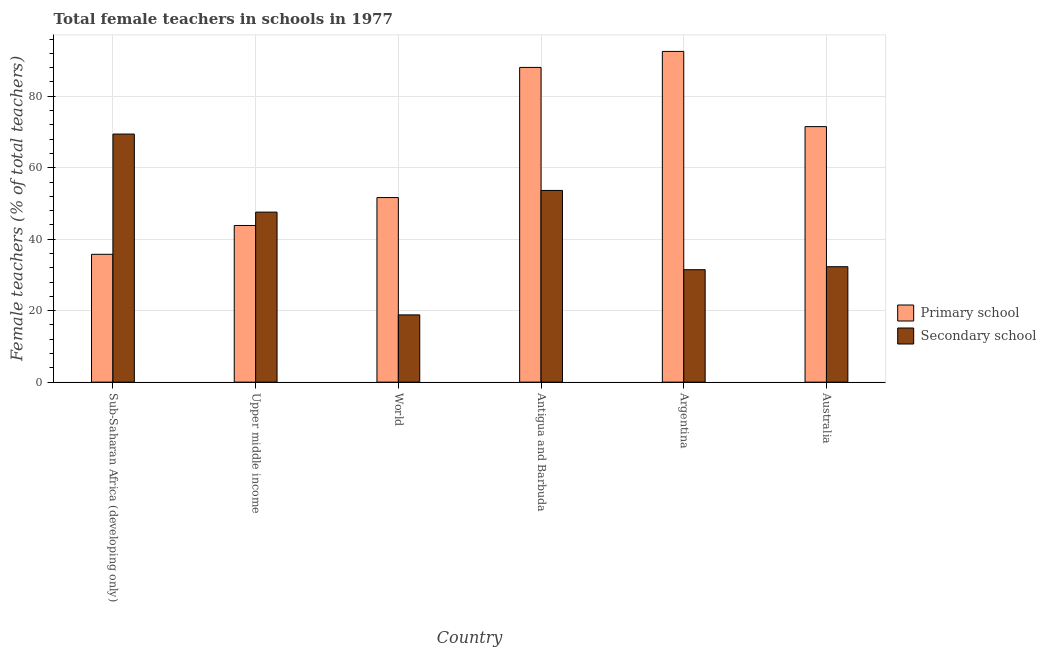How many different coloured bars are there?
Make the answer very short. 2. Are the number of bars per tick equal to the number of legend labels?
Make the answer very short. Yes. How many bars are there on the 2nd tick from the left?
Give a very brief answer. 2. How many bars are there on the 3rd tick from the right?
Make the answer very short. 2. What is the label of the 1st group of bars from the left?
Ensure brevity in your answer.  Sub-Saharan Africa (developing only). What is the percentage of female teachers in primary schools in Australia?
Your answer should be very brief. 71.5. Across all countries, what is the maximum percentage of female teachers in secondary schools?
Keep it short and to the point. 69.42. Across all countries, what is the minimum percentage of female teachers in secondary schools?
Provide a short and direct response. 18.82. In which country was the percentage of female teachers in secondary schools maximum?
Provide a succinct answer. Sub-Saharan Africa (developing only). In which country was the percentage of female teachers in primary schools minimum?
Your response must be concise. Sub-Saharan Africa (developing only). What is the total percentage of female teachers in secondary schools in the graph?
Your answer should be compact. 253.23. What is the difference between the percentage of female teachers in primary schools in Antigua and Barbuda and that in Australia?
Your answer should be very brief. 16.56. What is the difference between the percentage of female teachers in secondary schools in Upper middle income and the percentage of female teachers in primary schools in World?
Your response must be concise. -4.07. What is the average percentage of female teachers in secondary schools per country?
Offer a terse response. 42.21. What is the difference between the percentage of female teachers in secondary schools and percentage of female teachers in primary schools in Sub-Saharan Africa (developing only)?
Ensure brevity in your answer.  33.65. What is the ratio of the percentage of female teachers in primary schools in Antigua and Barbuda to that in World?
Your response must be concise. 1.71. Is the percentage of female teachers in primary schools in Sub-Saharan Africa (developing only) less than that in Upper middle income?
Offer a very short reply. Yes. What is the difference between the highest and the second highest percentage of female teachers in secondary schools?
Provide a short and direct response. 15.77. What is the difference between the highest and the lowest percentage of female teachers in primary schools?
Ensure brevity in your answer.  56.77. In how many countries, is the percentage of female teachers in primary schools greater than the average percentage of female teachers in primary schools taken over all countries?
Ensure brevity in your answer.  3. What does the 1st bar from the left in Sub-Saharan Africa (developing only) represents?
Keep it short and to the point. Primary school. What does the 1st bar from the right in Antigua and Barbuda represents?
Your answer should be very brief. Secondary school. Are all the bars in the graph horizontal?
Your answer should be very brief. No. How many countries are there in the graph?
Make the answer very short. 6. What is the difference between two consecutive major ticks on the Y-axis?
Provide a short and direct response. 20. Are the values on the major ticks of Y-axis written in scientific E-notation?
Provide a short and direct response. No. Does the graph contain grids?
Your response must be concise. Yes. Where does the legend appear in the graph?
Keep it short and to the point. Center right. How many legend labels are there?
Ensure brevity in your answer.  2. How are the legend labels stacked?
Keep it short and to the point. Vertical. What is the title of the graph?
Provide a short and direct response. Total female teachers in schools in 1977. Does "Official creditors" appear as one of the legend labels in the graph?
Ensure brevity in your answer.  No. What is the label or title of the Y-axis?
Provide a succinct answer. Female teachers (% of total teachers). What is the Female teachers (% of total teachers) of Primary school in Sub-Saharan Africa (developing only)?
Keep it short and to the point. 35.77. What is the Female teachers (% of total teachers) in Secondary school in Sub-Saharan Africa (developing only)?
Give a very brief answer. 69.42. What is the Female teachers (% of total teachers) in Primary school in Upper middle income?
Make the answer very short. 43.84. What is the Female teachers (% of total teachers) in Secondary school in Upper middle income?
Your answer should be compact. 47.58. What is the Female teachers (% of total teachers) of Primary school in World?
Your answer should be very brief. 51.65. What is the Female teachers (% of total teachers) in Secondary school in World?
Offer a very short reply. 18.82. What is the Female teachers (% of total teachers) in Primary school in Antigua and Barbuda?
Your answer should be compact. 88.07. What is the Female teachers (% of total teachers) of Secondary school in Antigua and Barbuda?
Provide a short and direct response. 53.65. What is the Female teachers (% of total teachers) in Primary school in Argentina?
Provide a short and direct response. 92.55. What is the Female teachers (% of total teachers) of Secondary school in Argentina?
Your answer should be compact. 31.47. What is the Female teachers (% of total teachers) in Primary school in Australia?
Your response must be concise. 71.5. What is the Female teachers (% of total teachers) in Secondary school in Australia?
Provide a short and direct response. 32.3. Across all countries, what is the maximum Female teachers (% of total teachers) of Primary school?
Your response must be concise. 92.55. Across all countries, what is the maximum Female teachers (% of total teachers) of Secondary school?
Offer a very short reply. 69.42. Across all countries, what is the minimum Female teachers (% of total teachers) of Primary school?
Your answer should be compact. 35.77. Across all countries, what is the minimum Female teachers (% of total teachers) of Secondary school?
Offer a very short reply. 18.82. What is the total Female teachers (% of total teachers) of Primary school in the graph?
Make the answer very short. 383.38. What is the total Female teachers (% of total teachers) in Secondary school in the graph?
Provide a short and direct response. 253.23. What is the difference between the Female teachers (% of total teachers) in Primary school in Sub-Saharan Africa (developing only) and that in Upper middle income?
Offer a very short reply. -8.06. What is the difference between the Female teachers (% of total teachers) of Secondary school in Sub-Saharan Africa (developing only) and that in Upper middle income?
Ensure brevity in your answer.  21.85. What is the difference between the Female teachers (% of total teachers) in Primary school in Sub-Saharan Africa (developing only) and that in World?
Give a very brief answer. -15.87. What is the difference between the Female teachers (% of total teachers) in Secondary school in Sub-Saharan Africa (developing only) and that in World?
Ensure brevity in your answer.  50.6. What is the difference between the Female teachers (% of total teachers) of Primary school in Sub-Saharan Africa (developing only) and that in Antigua and Barbuda?
Give a very brief answer. -52.29. What is the difference between the Female teachers (% of total teachers) of Secondary school in Sub-Saharan Africa (developing only) and that in Antigua and Barbuda?
Make the answer very short. 15.77. What is the difference between the Female teachers (% of total teachers) of Primary school in Sub-Saharan Africa (developing only) and that in Argentina?
Your answer should be very brief. -56.77. What is the difference between the Female teachers (% of total teachers) in Secondary school in Sub-Saharan Africa (developing only) and that in Argentina?
Give a very brief answer. 37.96. What is the difference between the Female teachers (% of total teachers) of Primary school in Sub-Saharan Africa (developing only) and that in Australia?
Make the answer very short. -35.73. What is the difference between the Female teachers (% of total teachers) in Secondary school in Sub-Saharan Africa (developing only) and that in Australia?
Offer a very short reply. 37.12. What is the difference between the Female teachers (% of total teachers) of Primary school in Upper middle income and that in World?
Keep it short and to the point. -7.81. What is the difference between the Female teachers (% of total teachers) of Secondary school in Upper middle income and that in World?
Make the answer very short. 28.76. What is the difference between the Female teachers (% of total teachers) in Primary school in Upper middle income and that in Antigua and Barbuda?
Make the answer very short. -44.23. What is the difference between the Female teachers (% of total teachers) of Secondary school in Upper middle income and that in Antigua and Barbuda?
Provide a succinct answer. -6.07. What is the difference between the Female teachers (% of total teachers) in Primary school in Upper middle income and that in Argentina?
Keep it short and to the point. -48.71. What is the difference between the Female teachers (% of total teachers) in Secondary school in Upper middle income and that in Argentina?
Offer a terse response. 16.11. What is the difference between the Female teachers (% of total teachers) in Primary school in Upper middle income and that in Australia?
Make the answer very short. -27.67. What is the difference between the Female teachers (% of total teachers) of Secondary school in Upper middle income and that in Australia?
Ensure brevity in your answer.  15.28. What is the difference between the Female teachers (% of total teachers) of Primary school in World and that in Antigua and Barbuda?
Provide a short and direct response. -36.42. What is the difference between the Female teachers (% of total teachers) of Secondary school in World and that in Antigua and Barbuda?
Your answer should be compact. -34.83. What is the difference between the Female teachers (% of total teachers) of Primary school in World and that in Argentina?
Your answer should be very brief. -40.9. What is the difference between the Female teachers (% of total teachers) in Secondary school in World and that in Argentina?
Make the answer very short. -12.65. What is the difference between the Female teachers (% of total teachers) in Primary school in World and that in Australia?
Offer a very short reply. -19.86. What is the difference between the Female teachers (% of total teachers) of Secondary school in World and that in Australia?
Your answer should be very brief. -13.48. What is the difference between the Female teachers (% of total teachers) in Primary school in Antigua and Barbuda and that in Argentina?
Your response must be concise. -4.48. What is the difference between the Female teachers (% of total teachers) of Secondary school in Antigua and Barbuda and that in Argentina?
Your answer should be very brief. 22.18. What is the difference between the Female teachers (% of total teachers) of Primary school in Antigua and Barbuda and that in Australia?
Ensure brevity in your answer.  16.56. What is the difference between the Female teachers (% of total teachers) of Secondary school in Antigua and Barbuda and that in Australia?
Provide a succinct answer. 21.35. What is the difference between the Female teachers (% of total teachers) in Primary school in Argentina and that in Australia?
Provide a short and direct response. 21.04. What is the difference between the Female teachers (% of total teachers) of Secondary school in Argentina and that in Australia?
Provide a short and direct response. -0.83. What is the difference between the Female teachers (% of total teachers) in Primary school in Sub-Saharan Africa (developing only) and the Female teachers (% of total teachers) in Secondary school in Upper middle income?
Your answer should be very brief. -11.8. What is the difference between the Female teachers (% of total teachers) of Primary school in Sub-Saharan Africa (developing only) and the Female teachers (% of total teachers) of Secondary school in World?
Your answer should be very brief. 16.95. What is the difference between the Female teachers (% of total teachers) in Primary school in Sub-Saharan Africa (developing only) and the Female teachers (% of total teachers) in Secondary school in Antigua and Barbuda?
Ensure brevity in your answer.  -17.87. What is the difference between the Female teachers (% of total teachers) in Primary school in Sub-Saharan Africa (developing only) and the Female teachers (% of total teachers) in Secondary school in Argentina?
Keep it short and to the point. 4.31. What is the difference between the Female teachers (% of total teachers) of Primary school in Sub-Saharan Africa (developing only) and the Female teachers (% of total teachers) of Secondary school in Australia?
Your answer should be compact. 3.47. What is the difference between the Female teachers (% of total teachers) in Primary school in Upper middle income and the Female teachers (% of total teachers) in Secondary school in World?
Offer a terse response. 25.02. What is the difference between the Female teachers (% of total teachers) of Primary school in Upper middle income and the Female teachers (% of total teachers) of Secondary school in Antigua and Barbuda?
Offer a terse response. -9.81. What is the difference between the Female teachers (% of total teachers) in Primary school in Upper middle income and the Female teachers (% of total teachers) in Secondary school in Argentina?
Make the answer very short. 12.37. What is the difference between the Female teachers (% of total teachers) in Primary school in Upper middle income and the Female teachers (% of total teachers) in Secondary school in Australia?
Offer a terse response. 11.54. What is the difference between the Female teachers (% of total teachers) of Primary school in World and the Female teachers (% of total teachers) of Secondary school in Antigua and Barbuda?
Make the answer very short. -2. What is the difference between the Female teachers (% of total teachers) in Primary school in World and the Female teachers (% of total teachers) in Secondary school in Argentina?
Your answer should be very brief. 20.18. What is the difference between the Female teachers (% of total teachers) in Primary school in World and the Female teachers (% of total teachers) in Secondary school in Australia?
Give a very brief answer. 19.35. What is the difference between the Female teachers (% of total teachers) in Primary school in Antigua and Barbuda and the Female teachers (% of total teachers) in Secondary school in Argentina?
Provide a short and direct response. 56.6. What is the difference between the Female teachers (% of total teachers) of Primary school in Antigua and Barbuda and the Female teachers (% of total teachers) of Secondary school in Australia?
Your answer should be compact. 55.77. What is the difference between the Female teachers (% of total teachers) in Primary school in Argentina and the Female teachers (% of total teachers) in Secondary school in Australia?
Ensure brevity in your answer.  60.25. What is the average Female teachers (% of total teachers) in Primary school per country?
Offer a terse response. 63.9. What is the average Female teachers (% of total teachers) in Secondary school per country?
Your answer should be very brief. 42.21. What is the difference between the Female teachers (% of total teachers) of Primary school and Female teachers (% of total teachers) of Secondary school in Sub-Saharan Africa (developing only)?
Give a very brief answer. -33.65. What is the difference between the Female teachers (% of total teachers) of Primary school and Female teachers (% of total teachers) of Secondary school in Upper middle income?
Keep it short and to the point. -3.74. What is the difference between the Female teachers (% of total teachers) in Primary school and Female teachers (% of total teachers) in Secondary school in World?
Keep it short and to the point. 32.83. What is the difference between the Female teachers (% of total teachers) in Primary school and Female teachers (% of total teachers) in Secondary school in Antigua and Barbuda?
Offer a terse response. 34.42. What is the difference between the Female teachers (% of total teachers) in Primary school and Female teachers (% of total teachers) in Secondary school in Argentina?
Your answer should be very brief. 61.08. What is the difference between the Female teachers (% of total teachers) in Primary school and Female teachers (% of total teachers) in Secondary school in Australia?
Your response must be concise. 39.2. What is the ratio of the Female teachers (% of total teachers) of Primary school in Sub-Saharan Africa (developing only) to that in Upper middle income?
Your response must be concise. 0.82. What is the ratio of the Female teachers (% of total teachers) in Secondary school in Sub-Saharan Africa (developing only) to that in Upper middle income?
Ensure brevity in your answer.  1.46. What is the ratio of the Female teachers (% of total teachers) in Primary school in Sub-Saharan Africa (developing only) to that in World?
Offer a very short reply. 0.69. What is the ratio of the Female teachers (% of total teachers) in Secondary school in Sub-Saharan Africa (developing only) to that in World?
Your response must be concise. 3.69. What is the ratio of the Female teachers (% of total teachers) of Primary school in Sub-Saharan Africa (developing only) to that in Antigua and Barbuda?
Give a very brief answer. 0.41. What is the ratio of the Female teachers (% of total teachers) of Secondary school in Sub-Saharan Africa (developing only) to that in Antigua and Barbuda?
Make the answer very short. 1.29. What is the ratio of the Female teachers (% of total teachers) in Primary school in Sub-Saharan Africa (developing only) to that in Argentina?
Your response must be concise. 0.39. What is the ratio of the Female teachers (% of total teachers) of Secondary school in Sub-Saharan Africa (developing only) to that in Argentina?
Keep it short and to the point. 2.21. What is the ratio of the Female teachers (% of total teachers) of Primary school in Sub-Saharan Africa (developing only) to that in Australia?
Provide a succinct answer. 0.5. What is the ratio of the Female teachers (% of total teachers) of Secondary school in Sub-Saharan Africa (developing only) to that in Australia?
Your answer should be compact. 2.15. What is the ratio of the Female teachers (% of total teachers) of Primary school in Upper middle income to that in World?
Provide a succinct answer. 0.85. What is the ratio of the Female teachers (% of total teachers) in Secondary school in Upper middle income to that in World?
Keep it short and to the point. 2.53. What is the ratio of the Female teachers (% of total teachers) in Primary school in Upper middle income to that in Antigua and Barbuda?
Provide a succinct answer. 0.5. What is the ratio of the Female teachers (% of total teachers) in Secondary school in Upper middle income to that in Antigua and Barbuda?
Your answer should be very brief. 0.89. What is the ratio of the Female teachers (% of total teachers) of Primary school in Upper middle income to that in Argentina?
Your answer should be very brief. 0.47. What is the ratio of the Female teachers (% of total teachers) of Secondary school in Upper middle income to that in Argentina?
Your answer should be compact. 1.51. What is the ratio of the Female teachers (% of total teachers) in Primary school in Upper middle income to that in Australia?
Make the answer very short. 0.61. What is the ratio of the Female teachers (% of total teachers) in Secondary school in Upper middle income to that in Australia?
Ensure brevity in your answer.  1.47. What is the ratio of the Female teachers (% of total teachers) in Primary school in World to that in Antigua and Barbuda?
Provide a succinct answer. 0.59. What is the ratio of the Female teachers (% of total teachers) of Secondary school in World to that in Antigua and Barbuda?
Offer a very short reply. 0.35. What is the ratio of the Female teachers (% of total teachers) of Primary school in World to that in Argentina?
Ensure brevity in your answer.  0.56. What is the ratio of the Female teachers (% of total teachers) of Secondary school in World to that in Argentina?
Provide a succinct answer. 0.6. What is the ratio of the Female teachers (% of total teachers) in Primary school in World to that in Australia?
Ensure brevity in your answer.  0.72. What is the ratio of the Female teachers (% of total teachers) of Secondary school in World to that in Australia?
Provide a succinct answer. 0.58. What is the ratio of the Female teachers (% of total teachers) of Primary school in Antigua and Barbuda to that in Argentina?
Your response must be concise. 0.95. What is the ratio of the Female teachers (% of total teachers) of Secondary school in Antigua and Barbuda to that in Argentina?
Your response must be concise. 1.71. What is the ratio of the Female teachers (% of total teachers) in Primary school in Antigua and Barbuda to that in Australia?
Ensure brevity in your answer.  1.23. What is the ratio of the Female teachers (% of total teachers) of Secondary school in Antigua and Barbuda to that in Australia?
Offer a terse response. 1.66. What is the ratio of the Female teachers (% of total teachers) in Primary school in Argentina to that in Australia?
Keep it short and to the point. 1.29. What is the ratio of the Female teachers (% of total teachers) of Secondary school in Argentina to that in Australia?
Your answer should be compact. 0.97. What is the difference between the highest and the second highest Female teachers (% of total teachers) in Primary school?
Your answer should be compact. 4.48. What is the difference between the highest and the second highest Female teachers (% of total teachers) in Secondary school?
Ensure brevity in your answer.  15.77. What is the difference between the highest and the lowest Female teachers (% of total teachers) of Primary school?
Offer a terse response. 56.77. What is the difference between the highest and the lowest Female teachers (% of total teachers) of Secondary school?
Ensure brevity in your answer.  50.6. 